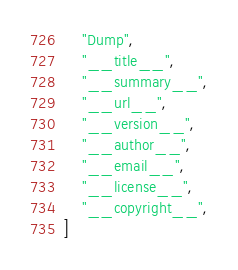Convert code to text. <code><loc_0><loc_0><loc_500><loc_500><_Python_>    "Dump",
    "__title__",
    "__summary__",
    "__url__",
    "__version__",
    "__author__",
    "__email__",
    "__license__",
    "__copyright__",
]
</code> 